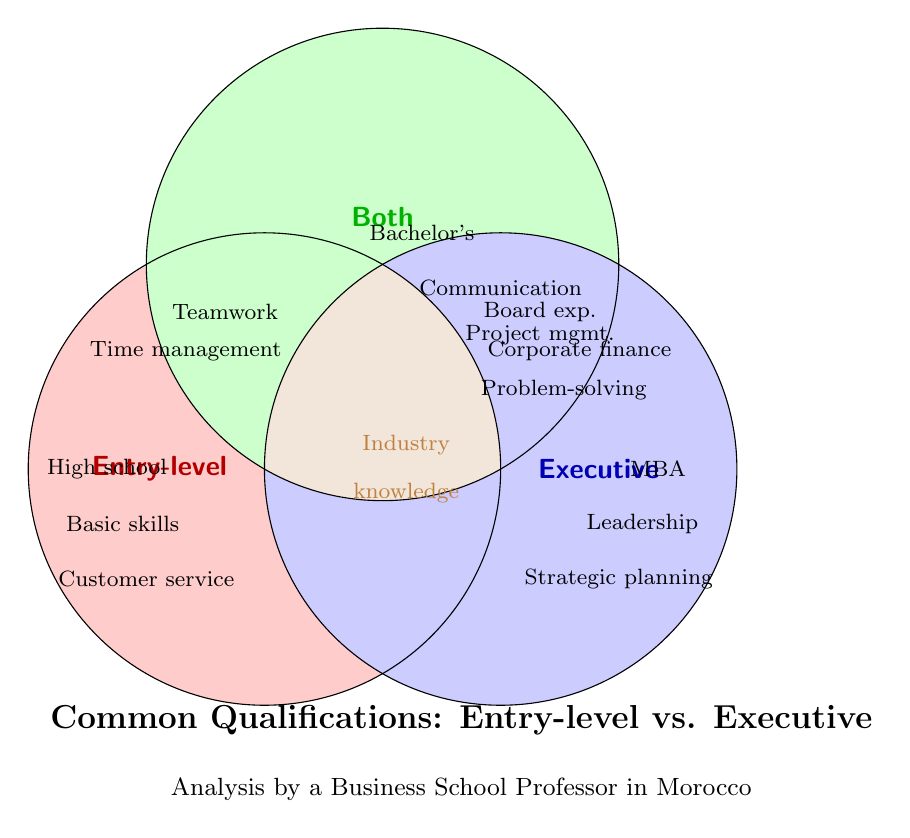What qualifications are exclusive to entry-level positions? By examining the Venn diagram, we can see that qualifications listed only within the 'Entry-level' circle without overlapping are exclusive to entry-level positions.
Answer: High school diploma, Basic computer skills, Customer service, Time management, Teamwork Which qualifications are common to both entry-level and executive positions? The qualifications that are listed within the overlapping circles between 'Entry-level' and 'Executive' are considered common. These are found in the 'Both' section of the diagram.
Answer: Bachelor's degree, Communication skills, Project management, Problem-solving, Networking, Industry knowledge, Presentation skills, Analytical thinking What qualifications are unique to executive positions? By focusing on the 'Executive' circle of the Venn diagram that does not overlap with any other circles, we can identify the unique qualifications for executive positions.
Answer: MBA, Leadership experience, Strategic planning, Corporate finance, Board experience, C-suite roles, Mergers & acquisitions, Global market insights Which qualification shared by both entry-level and executive positions involves managing tasks or projects? The qualifications that overlap in the 'Both' section and involve management must be identified.
Answer: Project management How many qualifications are common between entry-level and executive positions listed in the Venn diagram? Count the items listed in the overlapping 'Both' section of the Venn diagram to determine the common qualifications.
Answer: 8 Which section has qualifications related to communication? Look for the qualifications involving communication in all sections of the Venn diagram.
Answer: Both Which qualifications require advanced business know-how and are only for executive roles? Focusing on the 'Executive' section of the Venn diagram, we identify qualifications needing advanced business knowledge.
Answer: MBA, Strategic planning, Corporate finance, Board experience, C-suite roles, Mergers & acquisitions, Global market insights Are there more qualifications listed for entry-level or executive positions? By counting the qualifications in the 'Entry-level' circle and comparing them with those in the 'Executive' circle, we can determine which has more qualifications.
Answer: Executive Which entry-level qualification is most likely related to online platforms? Identify the qualifications in the 'Entry-level' section related to online tasks or platforms.
Answer: Social media literacy 